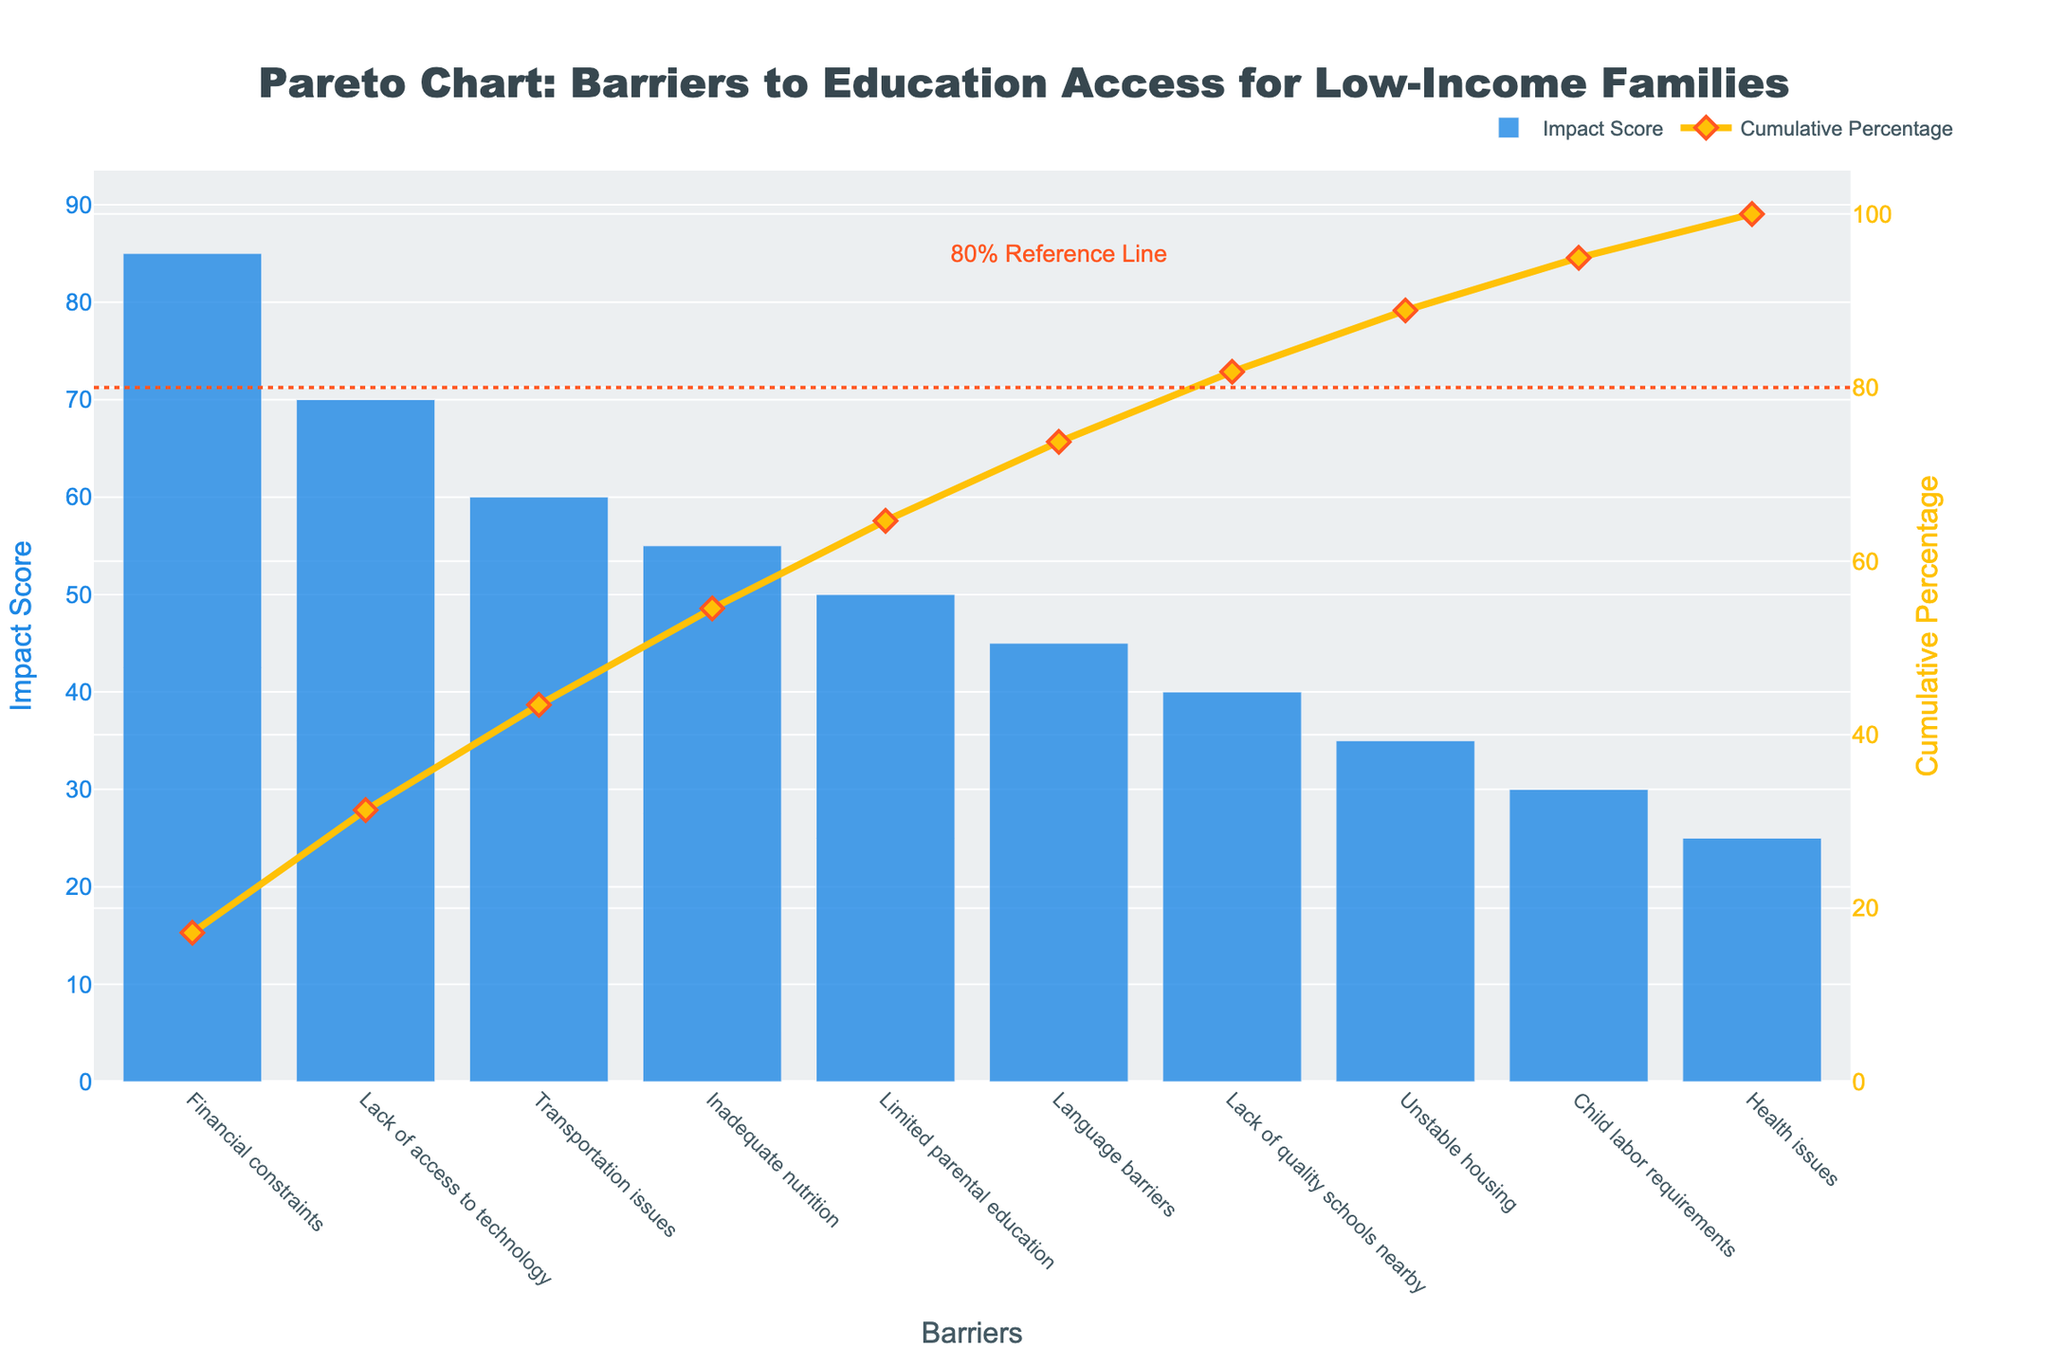What is the title of the chart? The title of the chart is displayed prominently at the top and reads: "Pareto Chart: Barriers to Education Access for Low-Income Families".
Answer: Pareto Chart: Barriers to Education Access for Low-Income Families What is the impact score of "Inadequate nutrition"? The impact score for each barrier is shown by the height of the blue bars. The "Inadequate nutrition" bar reaches the value of 55 on the y-axis.
Answer: 55 Which barrier has the highest impact score? By observing the length of the blue bars, the "Financial constraints" bar has the highest score, peaking at 85.
Answer: Financial constraints What is the cumulative percentage for the "Health issues" barrier? Refer to the line graph's points. The "Health issues" point lies at 100%, as it is the last data point on the x-axis.
Answer: 100% How many barriers have an impact score of 60 or higher? Locate the bars with heights at or above 60 on the y-axis. "Financial constraints" (85), "Lack of access to technology" (70), and "Transportation issues" (60) sum up to three bars.
Answer: 3 What is the difference in impact score between "Language barriers" and "Unstable housing"? "Language barriers" has a score of 45 while "Unstable housing" has 35. Subtract 35 from 45 to get the difference: 45 - 35 = 10.
Answer: 10 Which barriers together contribute to close to 80% of the cumulative impact? Observing the cumulative percentage line, "Financial constraints", "Lack of access to technology", "Transportation issues", and "Inadequate nutrition" together surpass 80%.
Answer: Financial constraints, Lack of access to technology, Transportation issues, Inadequate nutrition How is the 80% reference line marked? The 80% reference line appears as a horizontal dotted line in the plot, labeled with "80% Reference Line".
Answer: Dotted line Which barrier has the lowest impact score? Look at the bar with the smallest height, the "Health issues" bar, which peaks at 25 on the y-axis.
Answer: Health issues 